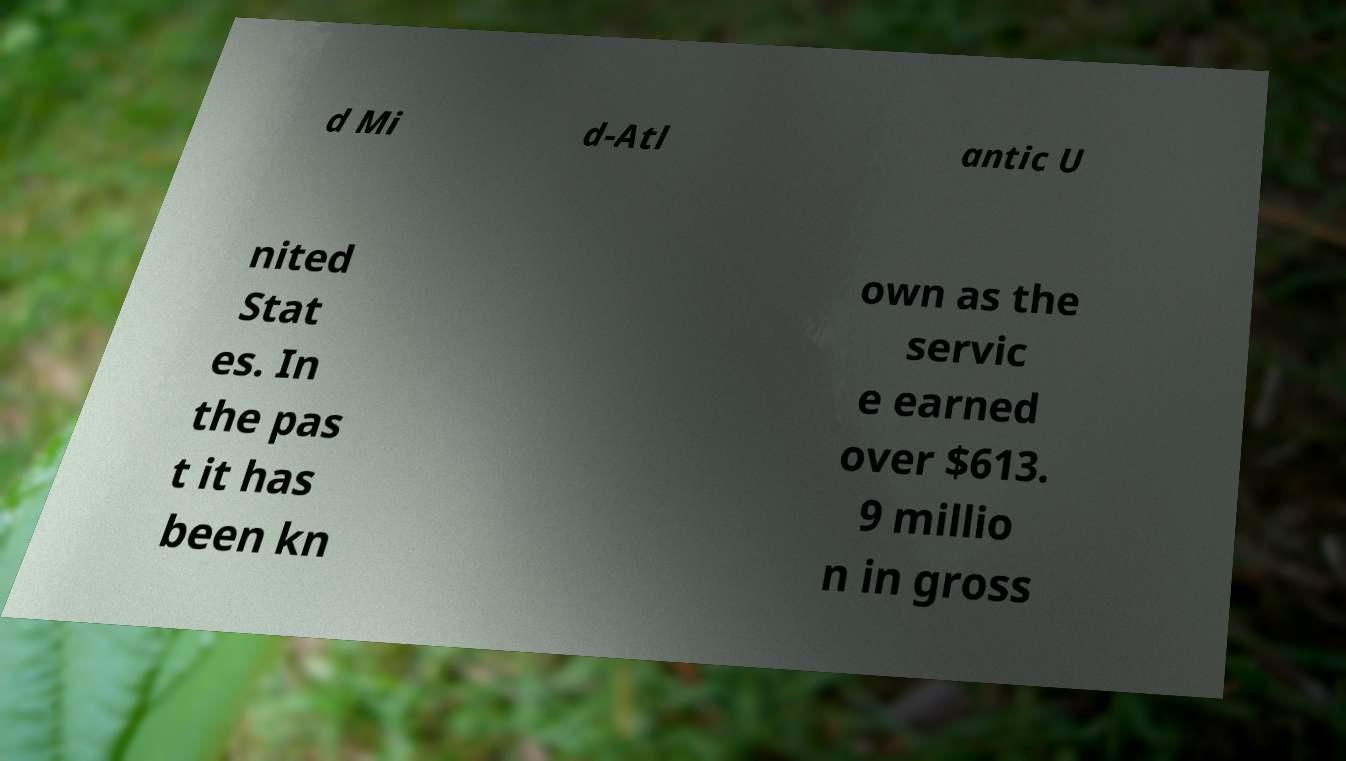Could you assist in decoding the text presented in this image and type it out clearly? d Mi d-Atl antic U nited Stat es. In the pas t it has been kn own as the servic e earned over $613. 9 millio n in gross 